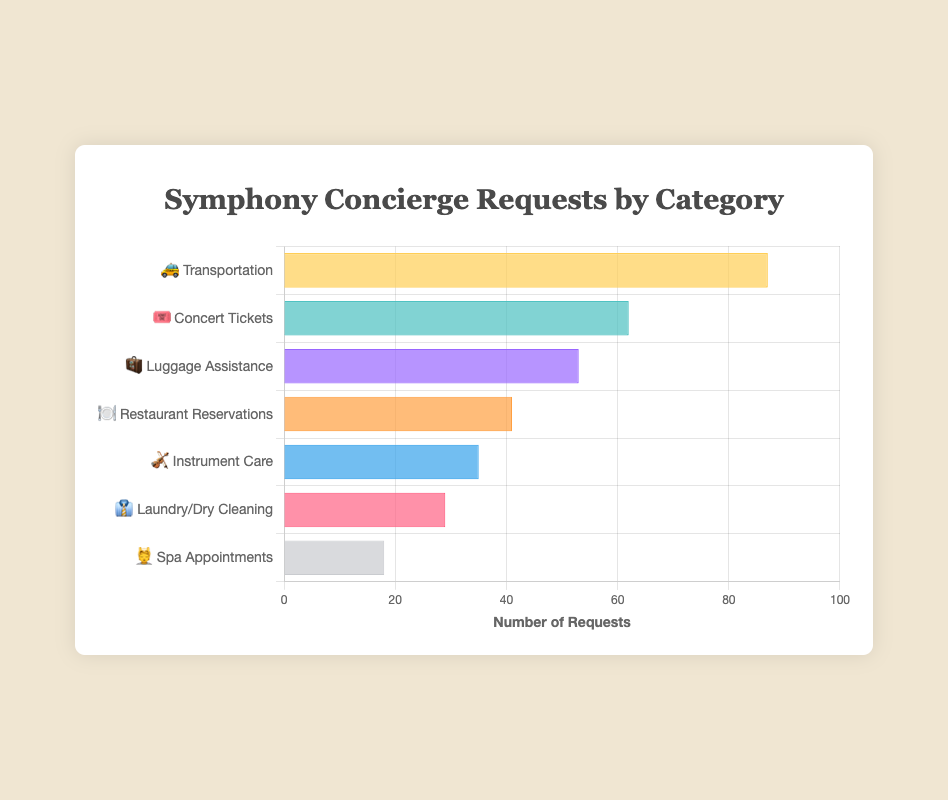What is the most requested service category? The most requested service category is indicated by the bar with the highest value. In this case, the service category with the emoji 🚕 (Transportation) has the highest number of requests, which is 87
Answer: Transportation 🚕 Which service category has the lowest number of requests? The service category with the lowest number of requests can be identified by the bar with the smallest value. The category with the emoji 💆 (Spa Appointments) has the lowest number of requests, which is 18
Answer: Spa Appointments 💆 What is the total number of requests for the top three service categories? To find the total number of requests for the top three service categories, sum the requests for the highest three categories: 87 (Transportation), 62 (Concert Tickets), and 53 (Luggage Assistance). Thus, 87 + 62 + 53 = 202 requests.
Answer: 202 Which service category has 6 more requests than Luggage Assistance? Luggage Assistance has 53 requests. The category with 6 more requests is 53 + 6 = 59. The closest service is Concert Tickets, which has 62 requests, nearest to the calculated value
Answer: Concert Tickets 🎟️ Rank the service categories in descending order based on their request numbers. To rank the categories, list them from the highest to the lowest number of requests: Transportation (87), Concert Tickets (62), Luggage Assistance (53), Restaurant Reservations (41), Instrument Care (35), Laundry/Dry Cleaning (29), Spa Appointments (18)
Answer: 🚕, 🎟️, 🧳, 🍽️, 🎻, 👔, 💆 What percentage of the total requests is for Restaurant Reservations? First, calculate the total number of requests: 87 + 62 + 53 + 41 + 35 + 29 + 18 = 325. Then, find the percentage for Restaurant Reservations: (41 / 325) * 100 ≈ 12.62%
Answer: 12.62% Which service categories have fewer than 30 requests? Identify categories with requests under 30: Laundry/Dry Cleaning (29), Spa Appointments (18)
Answer: 👔, 💆 For which service categories does the number of requests fall between 30 and 60? Identify categories with requests between 30 and 60: Concert Tickets (62), Luggage Assistance (53), Restaurant Reservations (41), Instrument Care (35)
Answer: 🎟️, 🧳, 🍽️, 🎻 